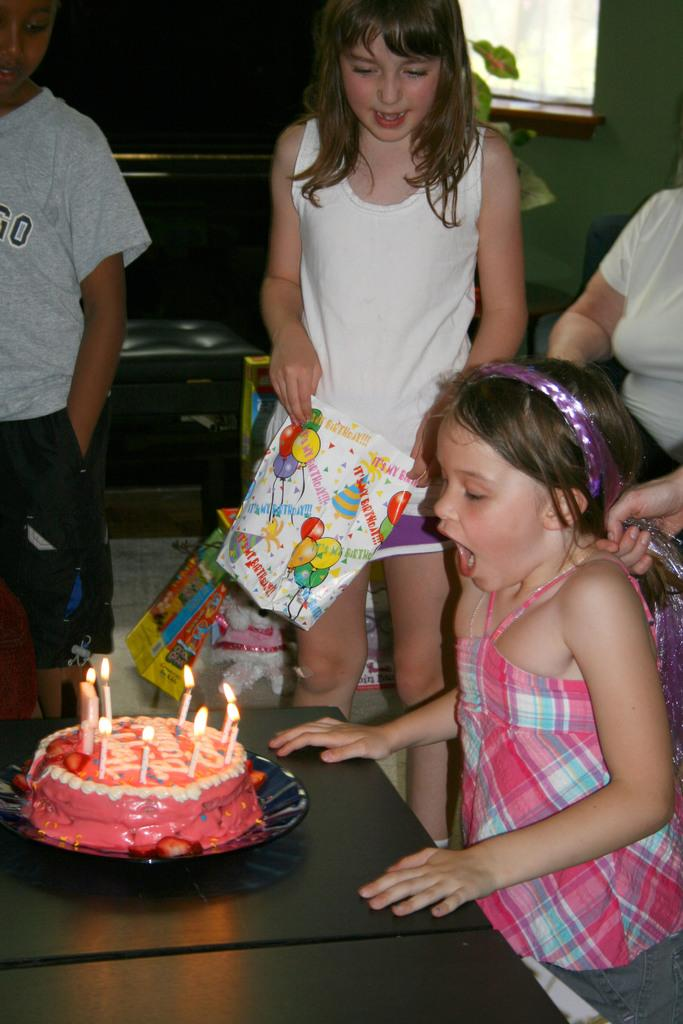Who can be seen in the image? There are people in the image, including a girl. What is on the table in the image? There is a cake on the table. What else can be found in the room besides the table and cake? There are other objects in the room. What type of cabbage is being used to decorate the cake in the image? There is no cabbage present in the image, and the cake is not being decorated with any vegetables. Can you tell me how many flights are visible in the image? There are no flights visible in the image, as it does not depict any airplanes or airports. 